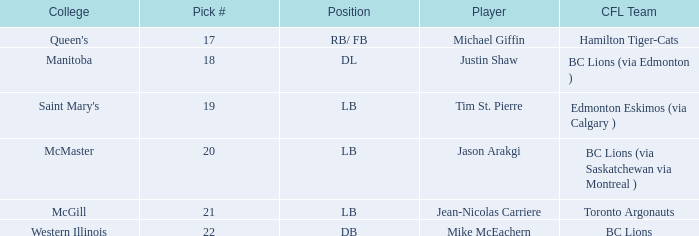What pick # did Western Illinois have? 22.0. 